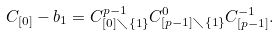<formula> <loc_0><loc_0><loc_500><loc_500>C _ { [ 0 ] } - b _ { 1 } = C ^ { p - 1 } _ { [ 0 ] \diagdown \{ 1 \} } C ^ { 0 } _ { [ p - 1 ] \diagdown \{ 1 \} } C ^ { - 1 } _ { [ p - 1 ] } .</formula> 